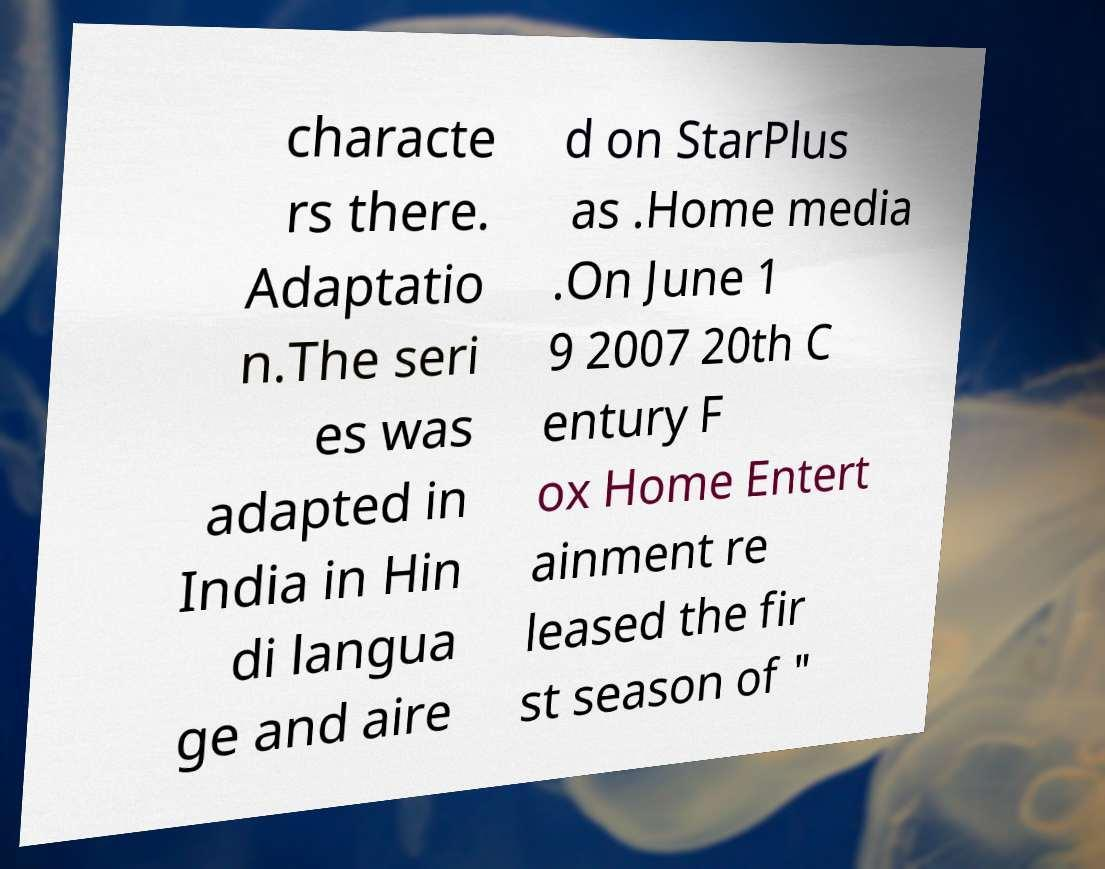For documentation purposes, I need the text within this image transcribed. Could you provide that? characte rs there. Adaptatio n.The seri es was adapted in India in Hin di langua ge and aire d on StarPlus as .Home media .On June 1 9 2007 20th C entury F ox Home Entert ainment re leased the fir st season of " 